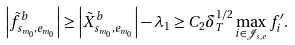Convert formula to latex. <formula><loc_0><loc_0><loc_500><loc_500>\left | \tilde { f } _ { s _ { m _ { 0 } } , e _ { m _ { 0 } } } ^ { b } \right | \geq \left | \tilde { X } _ { s _ { m _ { 0 } } , e _ { m _ { 0 } } } ^ { b } \right | - \lambda _ { 1 } \geq C _ { 2 } \delta _ { T } ^ { 1 / 2 } \max _ { i \in \mathcal { J } _ { s , e } } f ^ { \prime } _ { i } .</formula> 